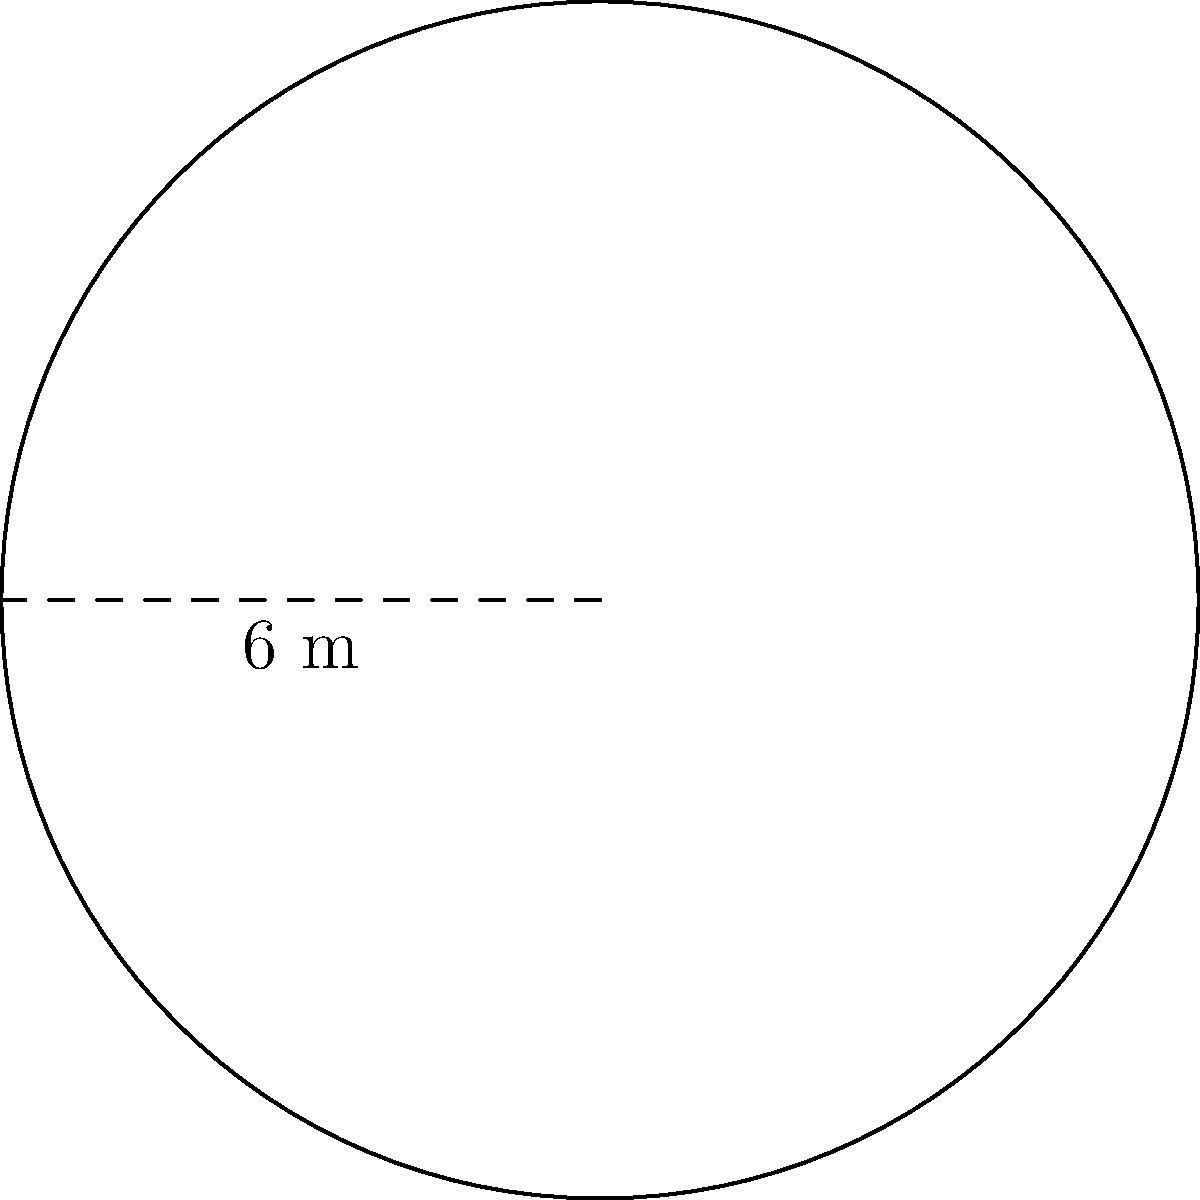You're auditioning for a role that requires you to perform on a circular stage platform. The director mentions that the stage has a radius of 3 meters. If you need to calculate the area of the stage to determine how many actors can fit comfortably, what is the total area of the circular stage platform in square meters? (Use $\pi \approx 3.14$) Let's solve this step-by-step:

1) The formula for the area of a circle is $A = \pi r^2$, where $r$ is the radius.

2) We're given that the radius is 3 meters.

3) Let's substitute these values into the formula:
   $A = \pi \cdot (3\text{ m})^2$

4) First, let's calculate the square of the radius:
   $(3\text{ m})^2 = 9\text{ m}^2$

5) Now, let's multiply by $\pi$:
   $A = \pi \cdot 9\text{ m}^2$

6) Using the approximation $\pi \approx 3.14$:
   $A \approx 3.14 \cdot 9\text{ m}^2 = 28.26\text{ m}^2$

Therefore, the area of the circular stage platform is approximately 28.26 square meters.
Answer: $28.26\text{ m}^2$ 